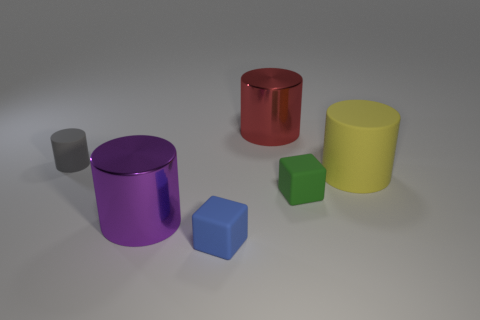How many green cubes have the same material as the big yellow object?
Keep it short and to the point. 1. Do the large object behind the yellow object and the big purple object have the same material?
Make the answer very short. Yes. Are there more big objects behind the green object than gray rubber objects behind the tiny matte cylinder?
Provide a short and direct response. Yes. What material is the purple thing that is the same size as the red thing?
Offer a terse response. Metal. How many other objects are there of the same material as the blue thing?
Your response must be concise. 3. Is the shape of the metal object in front of the red cylinder the same as the object that is in front of the purple cylinder?
Provide a short and direct response. No. What number of other objects are the same color as the tiny matte cylinder?
Your answer should be very brief. 0. Does the large object on the left side of the blue block have the same material as the small thing behind the yellow cylinder?
Give a very brief answer. No. Is the number of blue blocks that are behind the small green matte block the same as the number of yellow things that are in front of the big red object?
Make the answer very short. No. There is a big red thing behind the tiny green rubber block; what is its material?
Keep it short and to the point. Metal. 